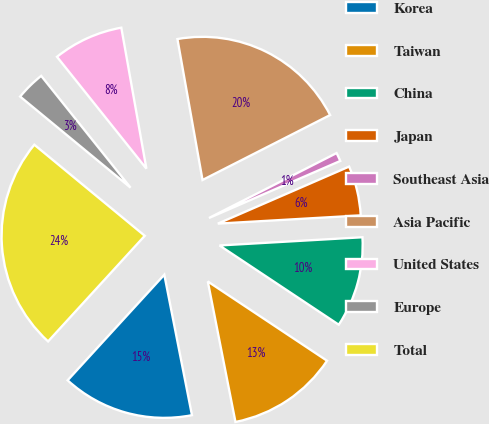Convert chart. <chart><loc_0><loc_0><loc_500><loc_500><pie_chart><fcel>Korea<fcel>Taiwan<fcel>China<fcel>Japan<fcel>Southeast Asia<fcel>Asia Pacific<fcel>United States<fcel>Europe<fcel>Total<nl><fcel>14.89%<fcel>12.57%<fcel>10.25%<fcel>5.61%<fcel>0.97%<fcel>20.31%<fcel>7.93%<fcel>3.29%<fcel>24.18%<nl></chart> 